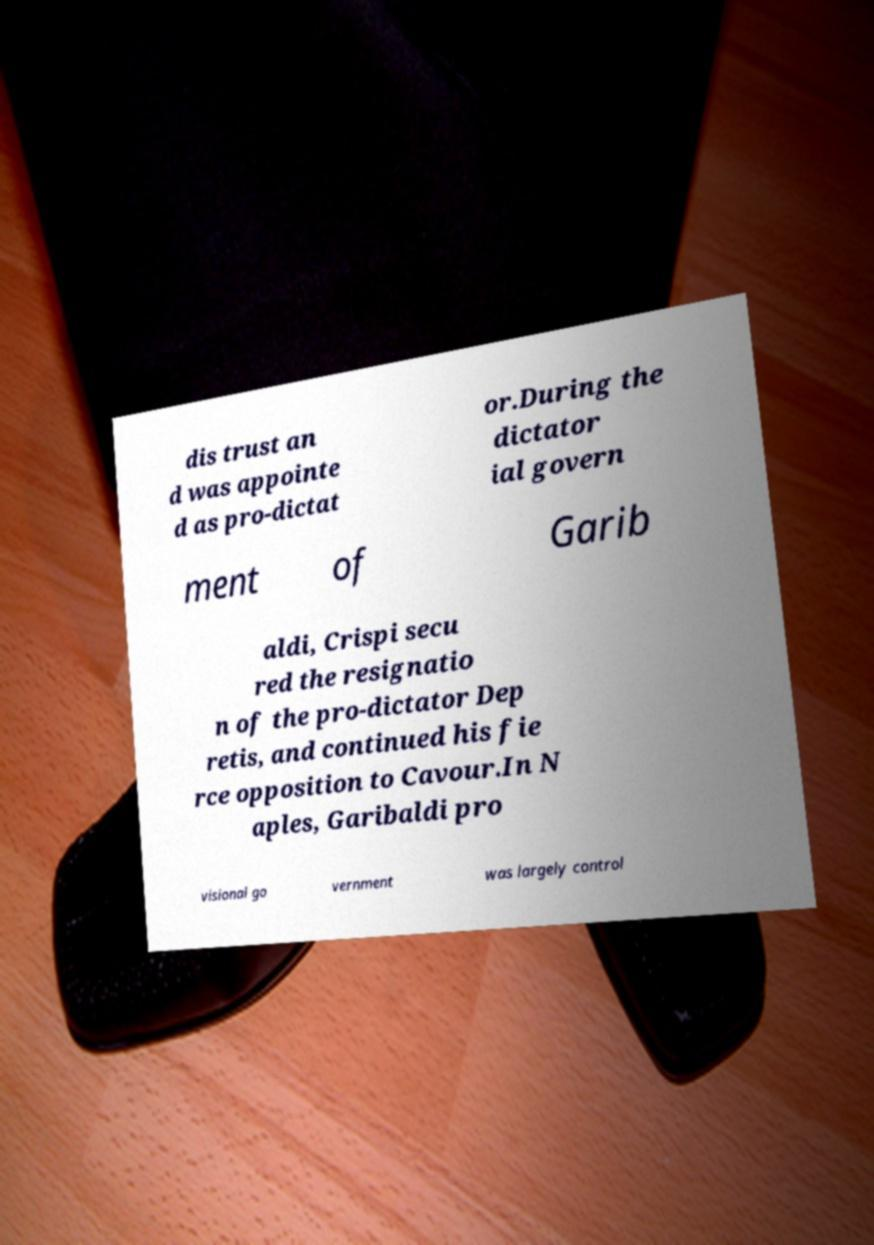Please read and relay the text visible in this image. What does it say? dis trust an d was appointe d as pro-dictat or.During the dictator ial govern ment of Garib aldi, Crispi secu red the resignatio n of the pro-dictator Dep retis, and continued his fie rce opposition to Cavour.In N aples, Garibaldi pro visional go vernment was largely control 